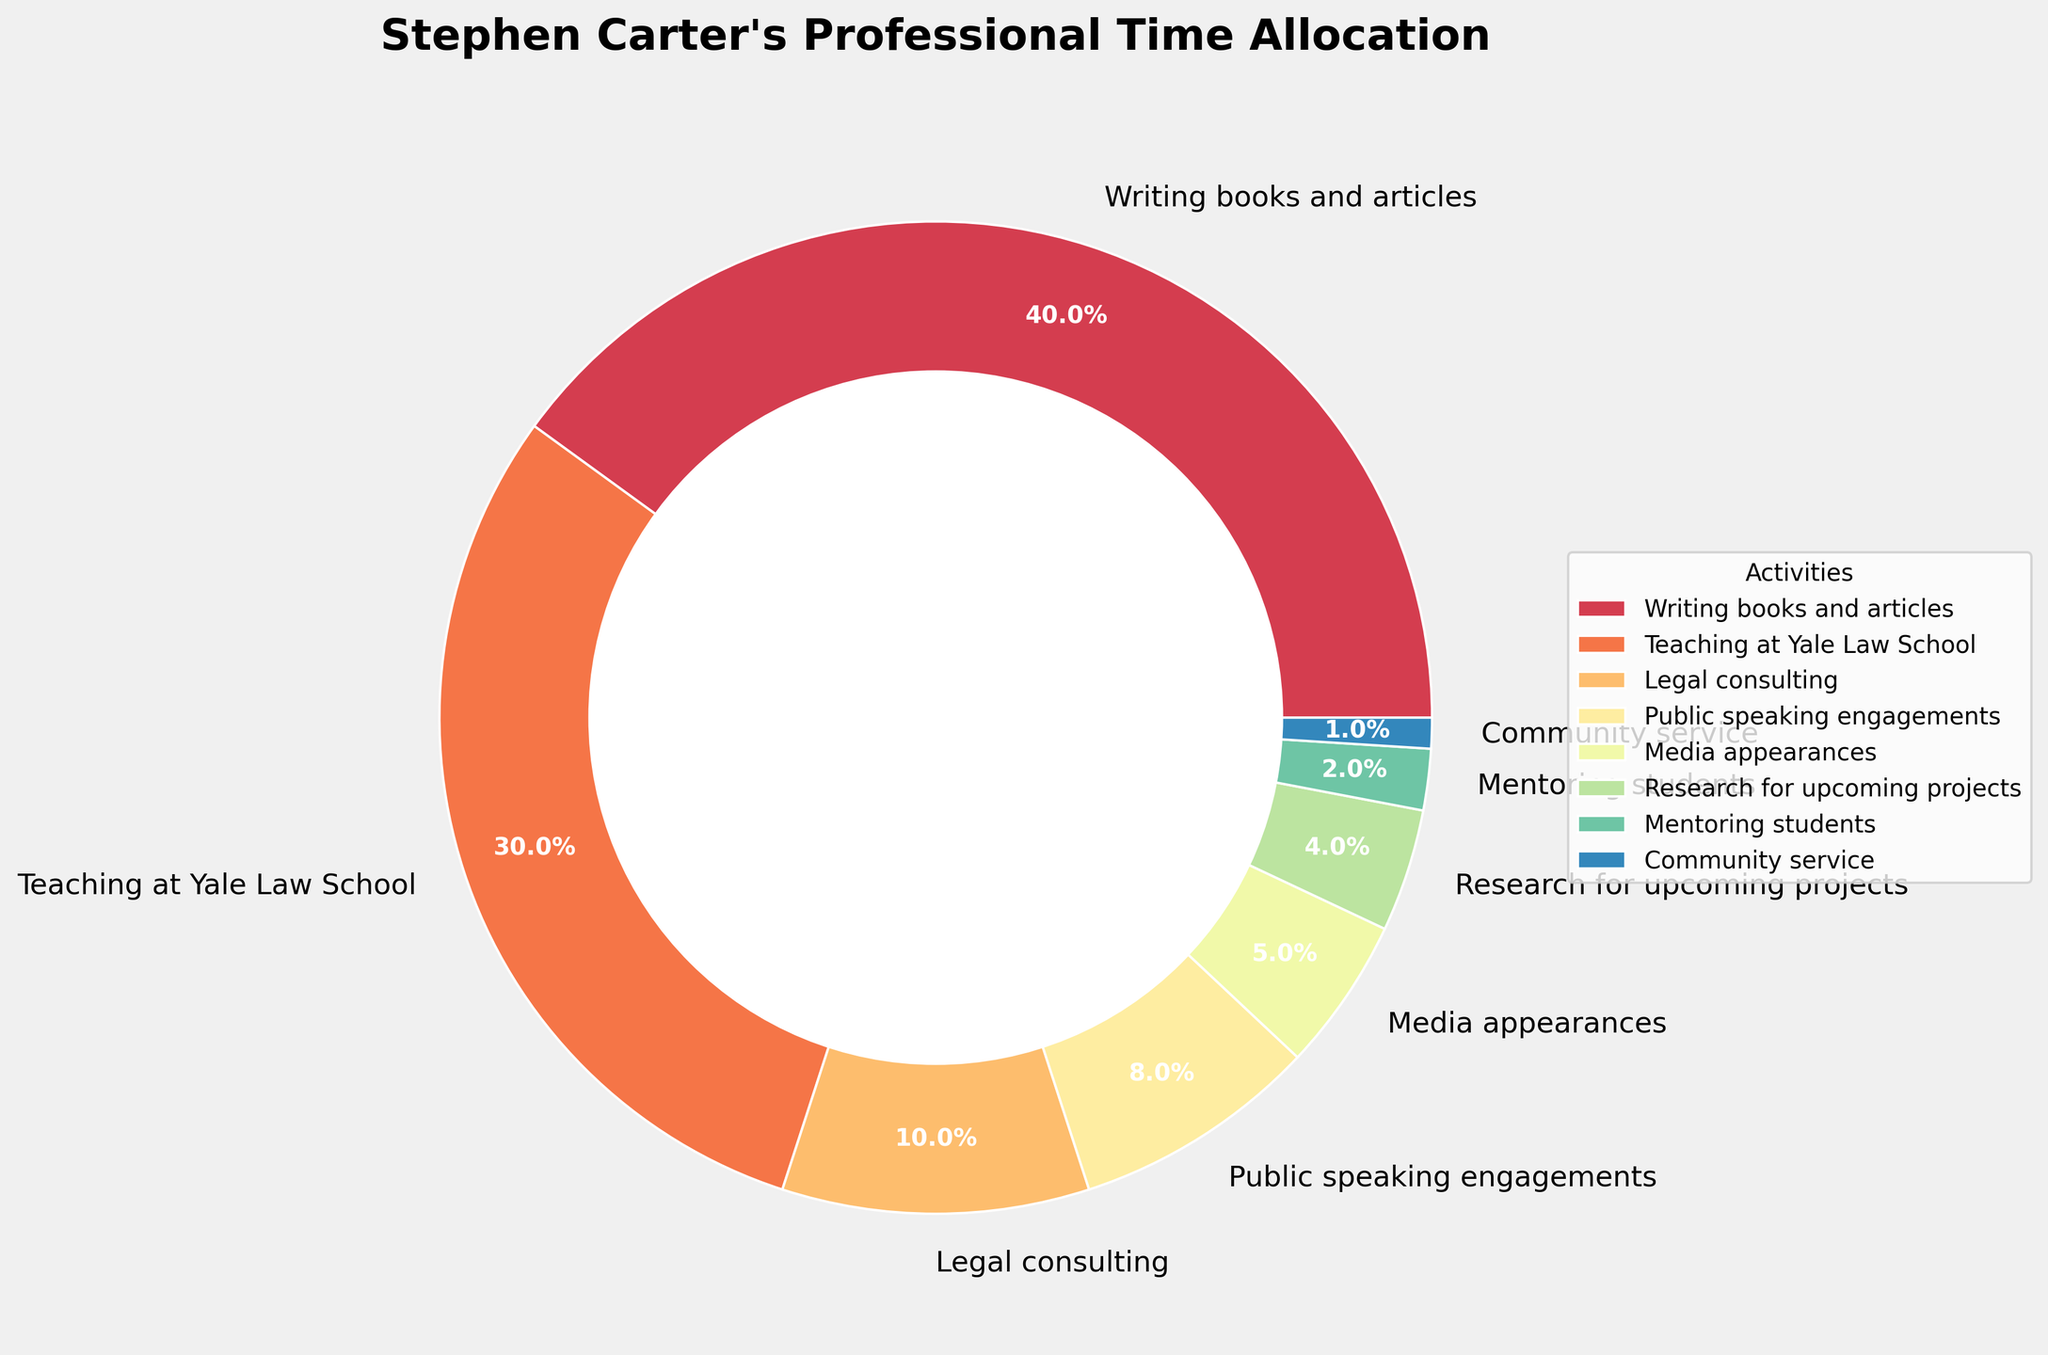What is the activity that takes up the largest portion of Carter's professional time? By comparing the percentages of all the activities, "Writing books and articles" has the highest percentage at 40%.
Answer: Writing books and articles How much more time does Carter spend on teaching compared to legal consulting? Carter spends 30% of his time on teaching and 10% on legal consulting. The difference is 30% - 10% = 20%.
Answer: 20% What is the combined percentage of Carter's time spent on community service and mentoring students? Carter spends 1% on community service and 2% on mentoring students. The sum is 1% + 2% = 3%.
Answer: 3% Which two activities consume a total of 14% of Carter's professional time? By observing the pie chart, public speaking engagements take up 8% and media appearances take up 5%. Adding these, we get 8% + 5% = 13%, which is close but not 14%. However, researching for upcoming projects is 4%, when combined with public speaking it gives 8% + 4% = 12%. However legal consulting at 10% plus community service at 1% gives 10% + 4% = 14%. Therefore legal consulting and community service together occupy 14%.
Answer: Legal consulting and community service Out of media appearances, public speaking engagements, and research for upcoming projects, which activity takes up the least amount of time? By referring to the chart, media appearances account for 5%, public speaking engagements for 8%, and research for upcoming projects for 4%. Therefore, research for upcoming projects takes the least amount of time.
Answer: Research for upcoming projects Which activity has the smallest slice in the pie chart? The smallest slice in the pie chart represents community service, which takes up 1% of Carter's professional time.
Answer: Community service Is the time spent on legal consulting greater than, less than, or equal to the time spent on research for upcoming projects and community service combined? Legal consulting takes 10% of Carter's time. Research for upcoming projects and community service combined is 4% + 1% = 5%. Hence, legal consulting takes more time.
Answer: Greater than What percentage of Carter's time is dedicated to activities other than writing and teaching? Writing takes 40% and teaching takes 30%, so together they take 70% of Carter's time. The remaining time is 100% - 70% = 30%.
Answer: 30% What is the average percentage of time spent on legal consulting, public speaking engagements, and media appearances? The percentages are 10%, 8%, and 5% respectively. The sum is 10% + 8% + 5% = 23%. The average is 23% / 3 = 7.67%.
Answer: 7.67% Which activity occupies a middle-range percentage of time in comparison to others? By comparing all activities, teaching at Yale Law School occupies 30%, which is neither the highest (40%) nor among the lowest percentages (1%, 2%, etc.).
Answer: Teaching at Yale Law School 